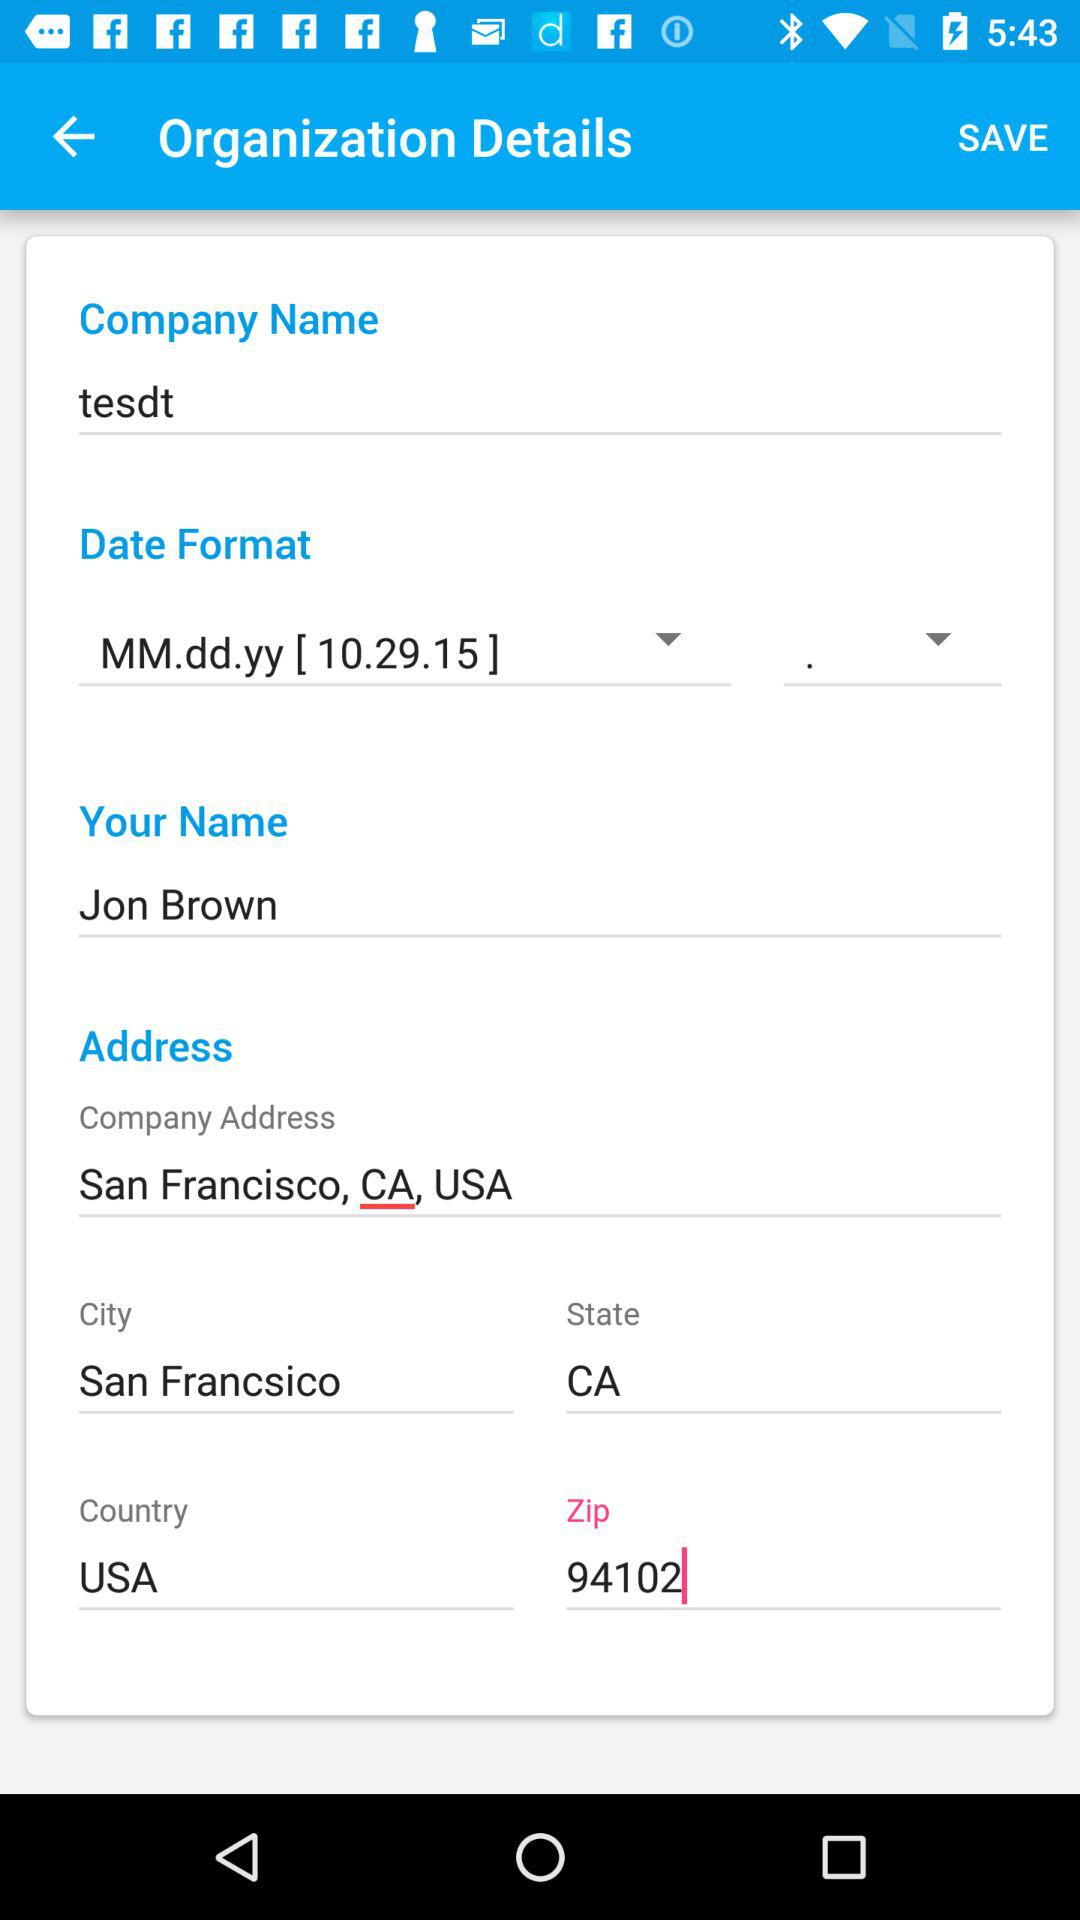What is the zip code? The zip code is 94102. 